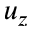<formula> <loc_0><loc_0><loc_500><loc_500>u _ { z }</formula> 